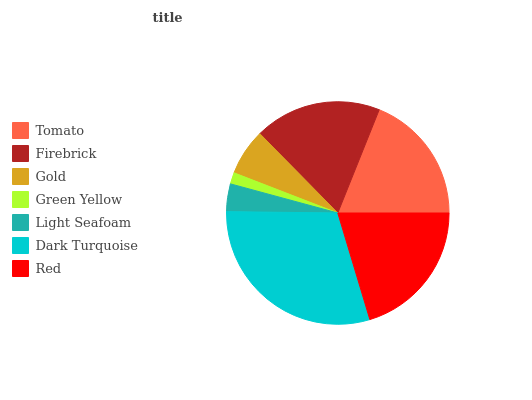Is Green Yellow the minimum?
Answer yes or no. Yes. Is Dark Turquoise the maximum?
Answer yes or no. Yes. Is Firebrick the minimum?
Answer yes or no. No. Is Firebrick the maximum?
Answer yes or no. No. Is Tomato greater than Firebrick?
Answer yes or no. Yes. Is Firebrick less than Tomato?
Answer yes or no. Yes. Is Firebrick greater than Tomato?
Answer yes or no. No. Is Tomato less than Firebrick?
Answer yes or no. No. Is Firebrick the high median?
Answer yes or no. Yes. Is Firebrick the low median?
Answer yes or no. Yes. Is Dark Turquoise the high median?
Answer yes or no. No. Is Gold the low median?
Answer yes or no. No. 